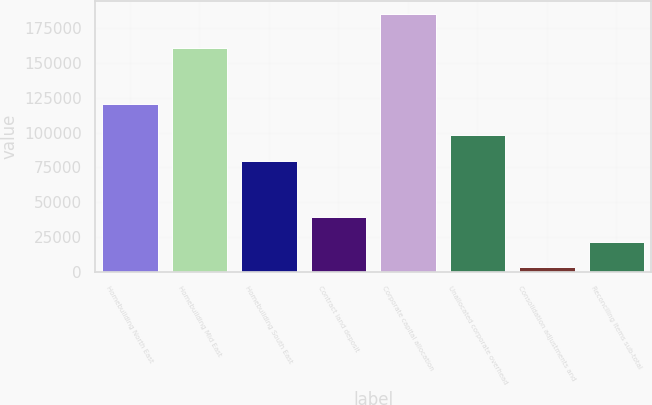Convert chart. <chart><loc_0><loc_0><loc_500><loc_500><bar_chart><fcel>Homebuilding North East<fcel>Homebuilding Mid East<fcel>Homebuilding South East<fcel>Contract land deposit<fcel>Corporate capital allocation<fcel>Unallocated corporate overhead<fcel>Consolidation adjustments and<fcel>Reconciling items sub-total<nl><fcel>120531<fcel>160494<fcel>79948<fcel>39653.6<fcel>184908<fcel>98104.8<fcel>3340<fcel>21496.8<nl></chart> 